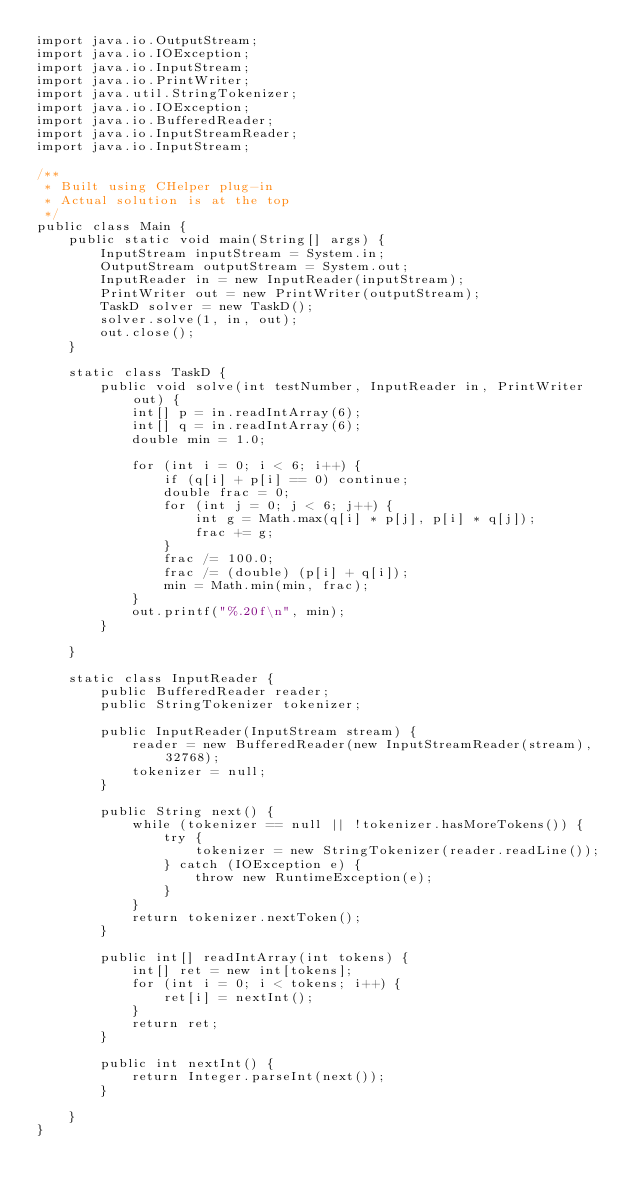Convert code to text. <code><loc_0><loc_0><loc_500><loc_500><_Java_>import java.io.OutputStream;
import java.io.IOException;
import java.io.InputStream;
import java.io.PrintWriter;
import java.util.StringTokenizer;
import java.io.IOException;
import java.io.BufferedReader;
import java.io.InputStreamReader;
import java.io.InputStream;

/**
 * Built using CHelper plug-in
 * Actual solution is at the top
 */
public class Main {
    public static void main(String[] args) {
        InputStream inputStream = System.in;
        OutputStream outputStream = System.out;
        InputReader in = new InputReader(inputStream);
        PrintWriter out = new PrintWriter(outputStream);
        TaskD solver = new TaskD();
        solver.solve(1, in, out);
        out.close();
    }

    static class TaskD {
        public void solve(int testNumber, InputReader in, PrintWriter out) {
            int[] p = in.readIntArray(6);
            int[] q = in.readIntArray(6);
            double min = 1.0;

            for (int i = 0; i < 6; i++) {
                if (q[i] + p[i] == 0) continue;
                double frac = 0;
                for (int j = 0; j < 6; j++) {
                    int g = Math.max(q[i] * p[j], p[i] * q[j]);
                    frac += g;
                }
                frac /= 100.0;
                frac /= (double) (p[i] + q[i]);
                min = Math.min(min, frac);
            }
            out.printf("%.20f\n", min);
        }

    }

    static class InputReader {
        public BufferedReader reader;
        public StringTokenizer tokenizer;

        public InputReader(InputStream stream) {
            reader = new BufferedReader(new InputStreamReader(stream), 32768);
            tokenizer = null;
        }

        public String next() {
            while (tokenizer == null || !tokenizer.hasMoreTokens()) {
                try {
                    tokenizer = new StringTokenizer(reader.readLine());
                } catch (IOException e) {
                    throw new RuntimeException(e);
                }
            }
            return tokenizer.nextToken();
        }

        public int[] readIntArray(int tokens) {
            int[] ret = new int[tokens];
            for (int i = 0; i < tokens; i++) {
                ret[i] = nextInt();
            }
            return ret;
        }

        public int nextInt() {
            return Integer.parseInt(next());
        }

    }
}

</code> 